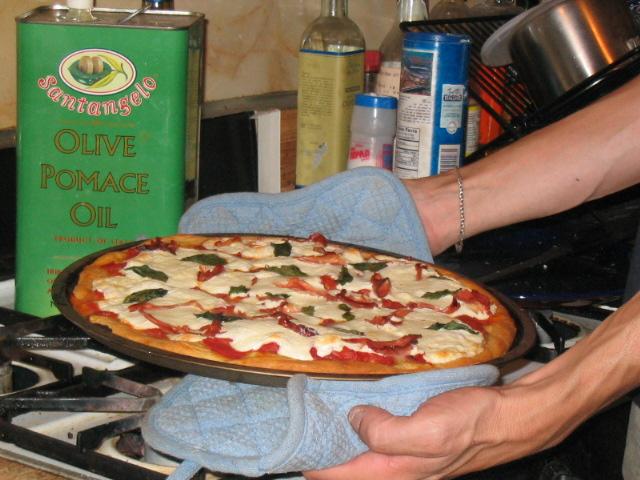What is the person using to hold pan?
Short answer required. Pot holders. How many pots in the picture?
Concise answer only. 1. What brand is the olive oil?
Be succinct. Santangelo. Is that a gas stove or an electric stove?
Keep it brief. Gas. 